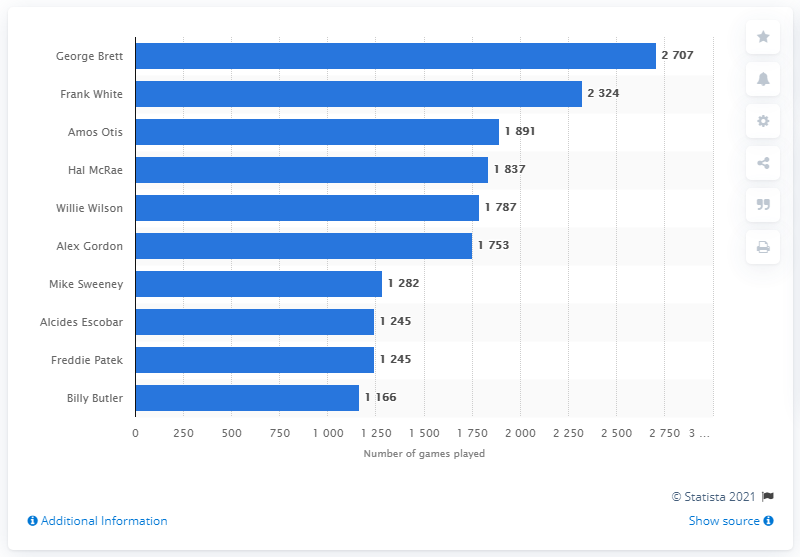Give some essential details in this illustration. George Brett is the player who has played the most games in the history of the Kansas City Royals franchise. 